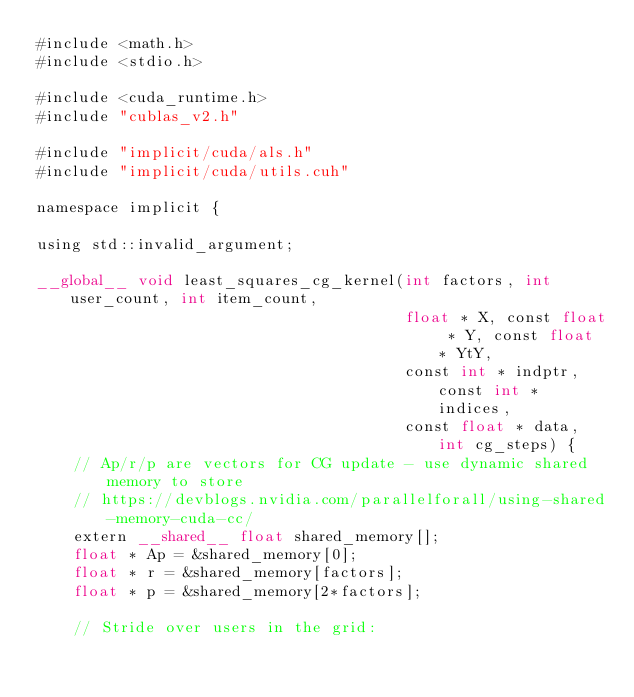<code> <loc_0><loc_0><loc_500><loc_500><_Cuda_>#include <math.h>
#include <stdio.h>

#include <cuda_runtime.h>
#include "cublas_v2.h"

#include "implicit/cuda/als.h"
#include "implicit/cuda/utils.cuh"

namespace implicit {

using std::invalid_argument;

__global__ void least_squares_cg_kernel(int factors, int user_count, int item_count,
                                        float * X, const float * Y, const float * YtY,
                                        const int * indptr, const int * indices,
                                        const float * data, int cg_steps) {
    // Ap/r/p are vectors for CG update - use dynamic shared memory to store
    // https://devblogs.nvidia.com/parallelforall/using-shared-memory-cuda-cc/
    extern __shared__ float shared_memory[];
    float * Ap = &shared_memory[0];
    float * r = &shared_memory[factors];
    float * p = &shared_memory[2*factors];

    // Stride over users in the grid:</code> 